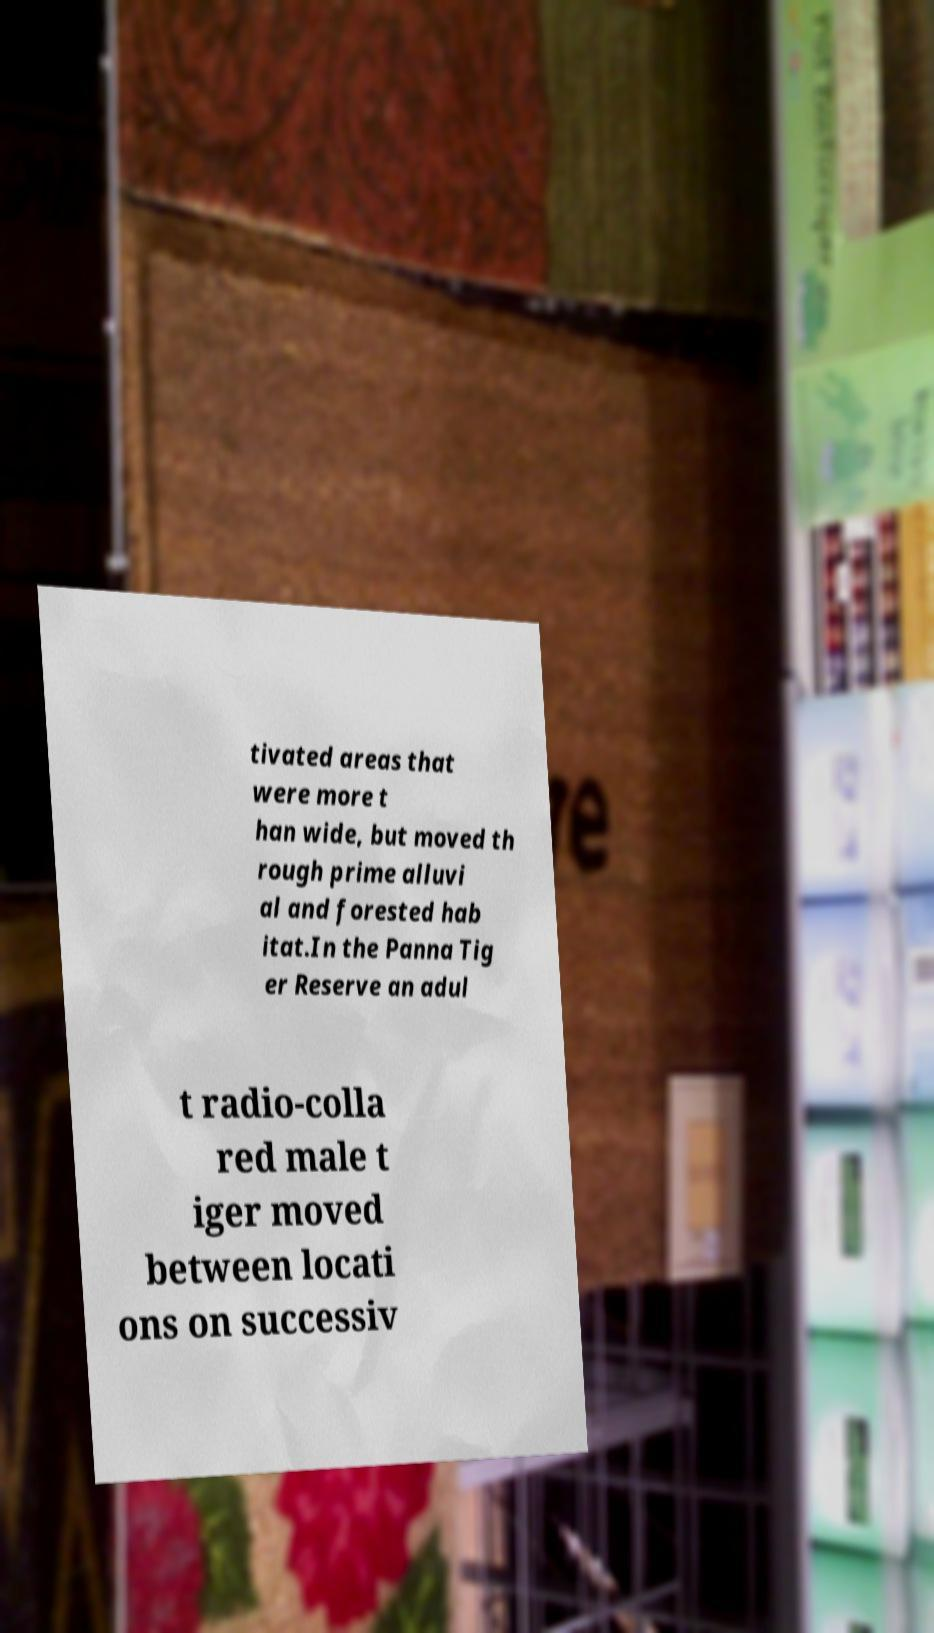Could you extract and type out the text from this image? tivated areas that were more t han wide, but moved th rough prime alluvi al and forested hab itat.In the Panna Tig er Reserve an adul t radio-colla red male t iger moved between locati ons on successiv 